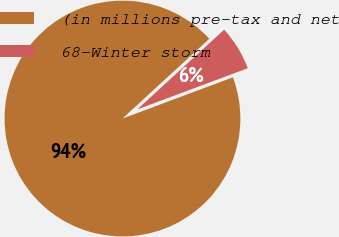<chart> <loc_0><loc_0><loc_500><loc_500><pie_chart><fcel>(in millions pre-tax and net<fcel>68-Winter storm<nl><fcel>93.86%<fcel>6.14%<nl></chart> 